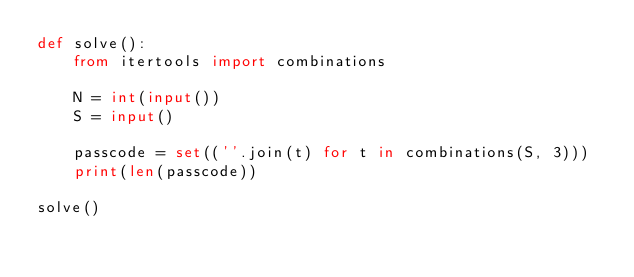<code> <loc_0><loc_0><loc_500><loc_500><_Python_>def solve():
    from itertools import combinations
    
    N = int(input())
    S = input()
    
    passcode = set((''.join(t) for t in combinations(S, 3)))
    print(len(passcode))

solve()</code> 